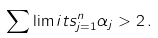<formula> <loc_0><loc_0><loc_500><loc_500>\sum \lim i t s _ { j = 1 } ^ { n } \alpha _ { j } > 2 \, .</formula> 